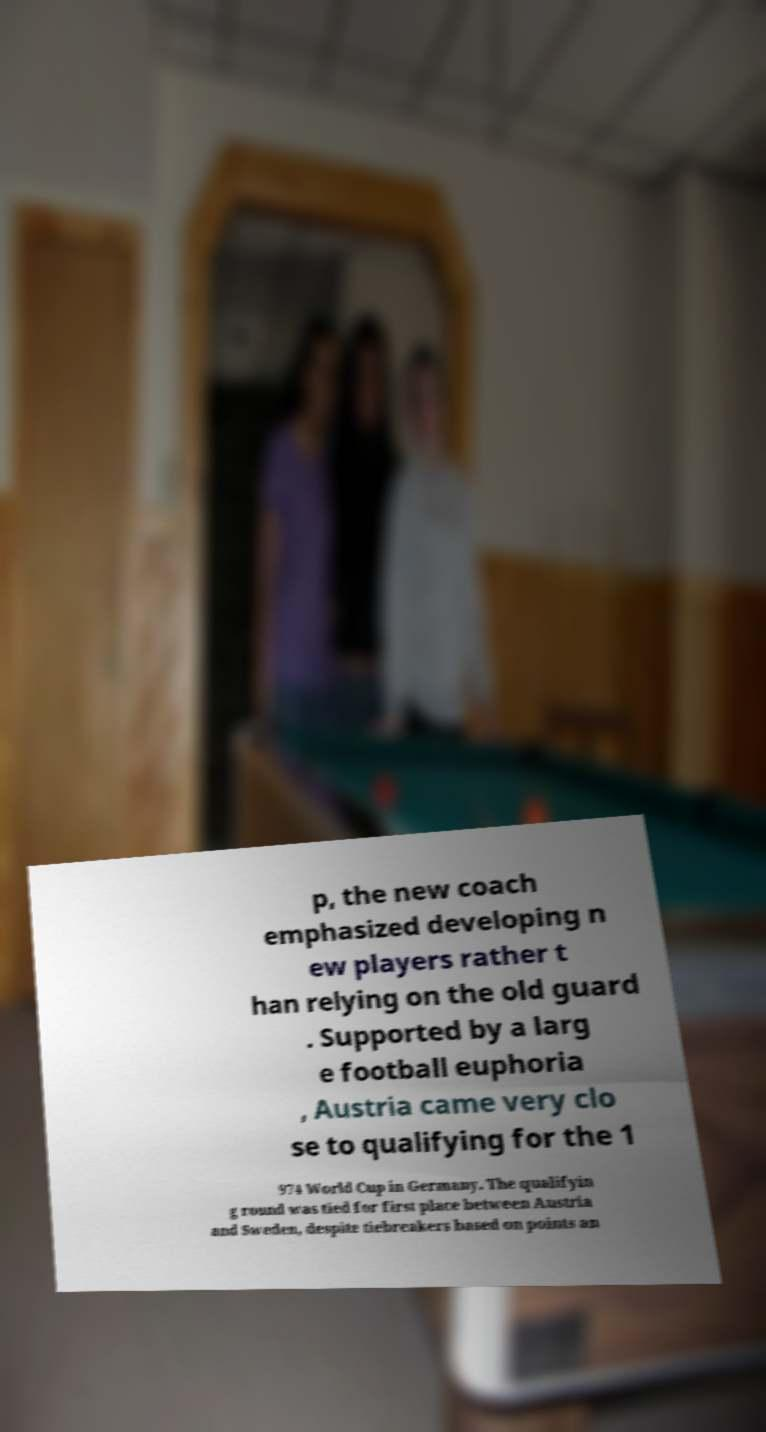Could you assist in decoding the text presented in this image and type it out clearly? p, the new coach emphasized developing n ew players rather t han relying on the old guard . Supported by a larg e football euphoria , Austria came very clo se to qualifying for the 1 974 World Cup in Germany. The qualifyin g round was tied for first place between Austria and Sweden, despite tiebreakers based on points an 